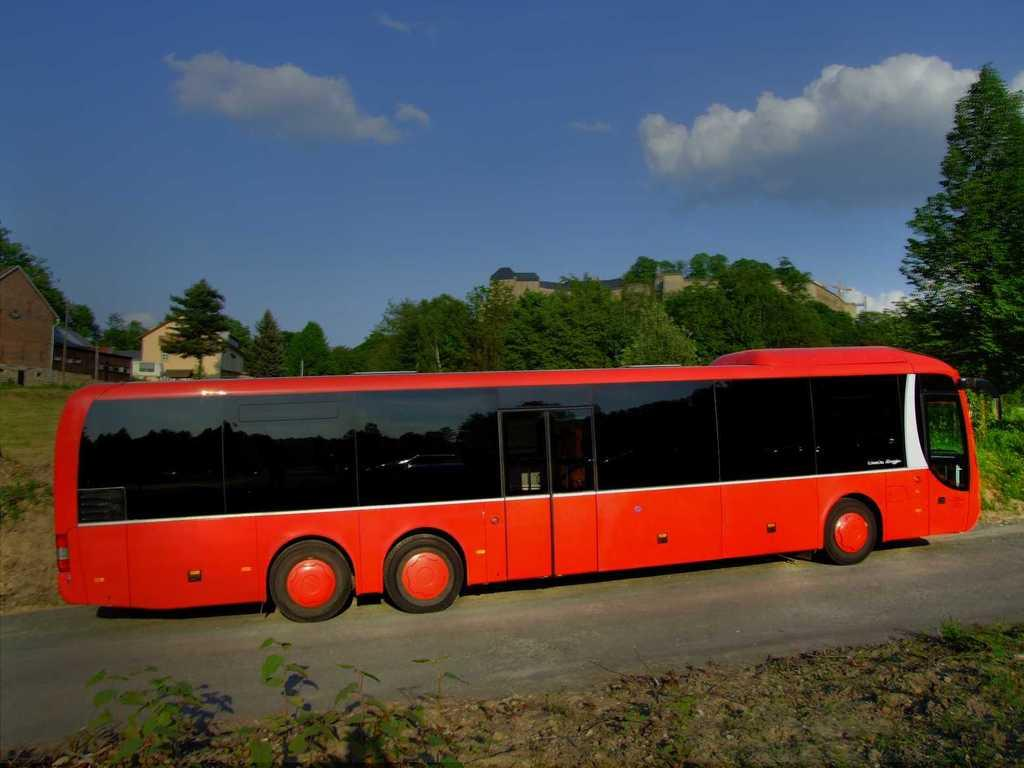What is the main subject in the center of the image? There is a bus in the center of the image. Where is the bus located? The bus is on the road. What can be seen in the background of the image? There are sheds, trees, and the sky visible in the background of the image. Can you see any bones in the image? There are no bones present in the image. What type of playground equipment can be seen in the image? There is no playground equipment visible in the image. 